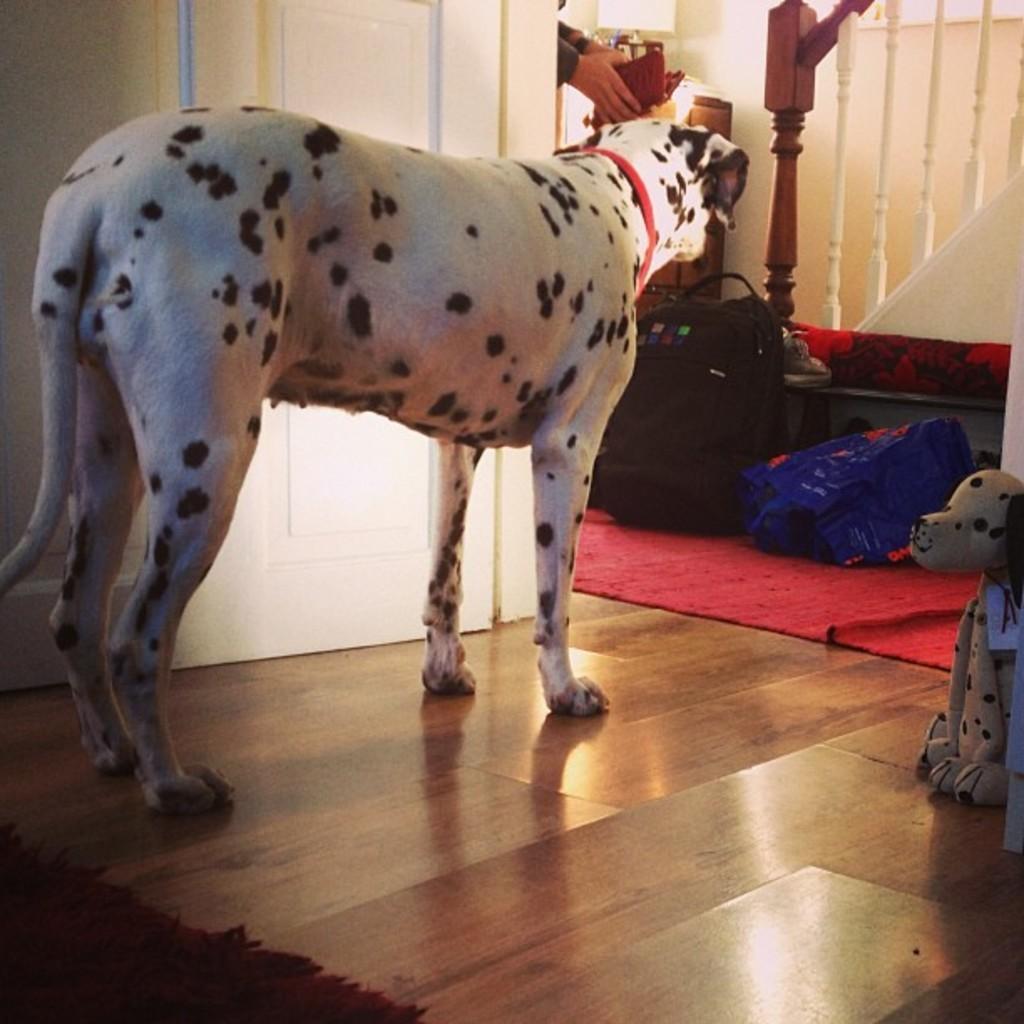In one or two sentences, can you explain what this image depicts? There is a dog in the center of the image and there is a door behind it. There is a toy on the right side, there is a rug in the bottom left side and there are bags on the floor, a lamp on a deck, railing and a person in the background area. 